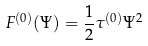<formula> <loc_0><loc_0><loc_500><loc_500>F ^ { ( 0 ) } ( \Psi ) = \frac { 1 } { 2 } \tau ^ { ( 0 ) } \Psi ^ { 2 }</formula> 